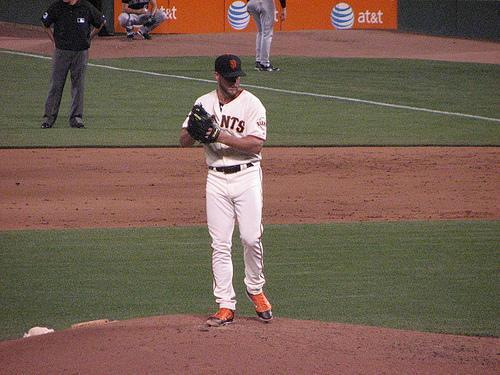How many people are pictured?
Give a very brief answer. 4. 